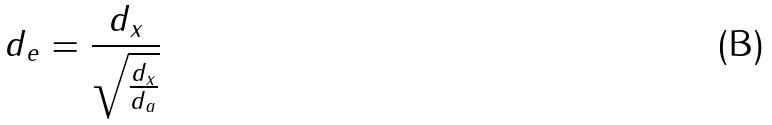Convert formula to latex. <formula><loc_0><loc_0><loc_500><loc_500>d _ { e } = \frac { d _ { x } } { \sqrt { \frac { d _ { x } } { d _ { a } } } }</formula> 